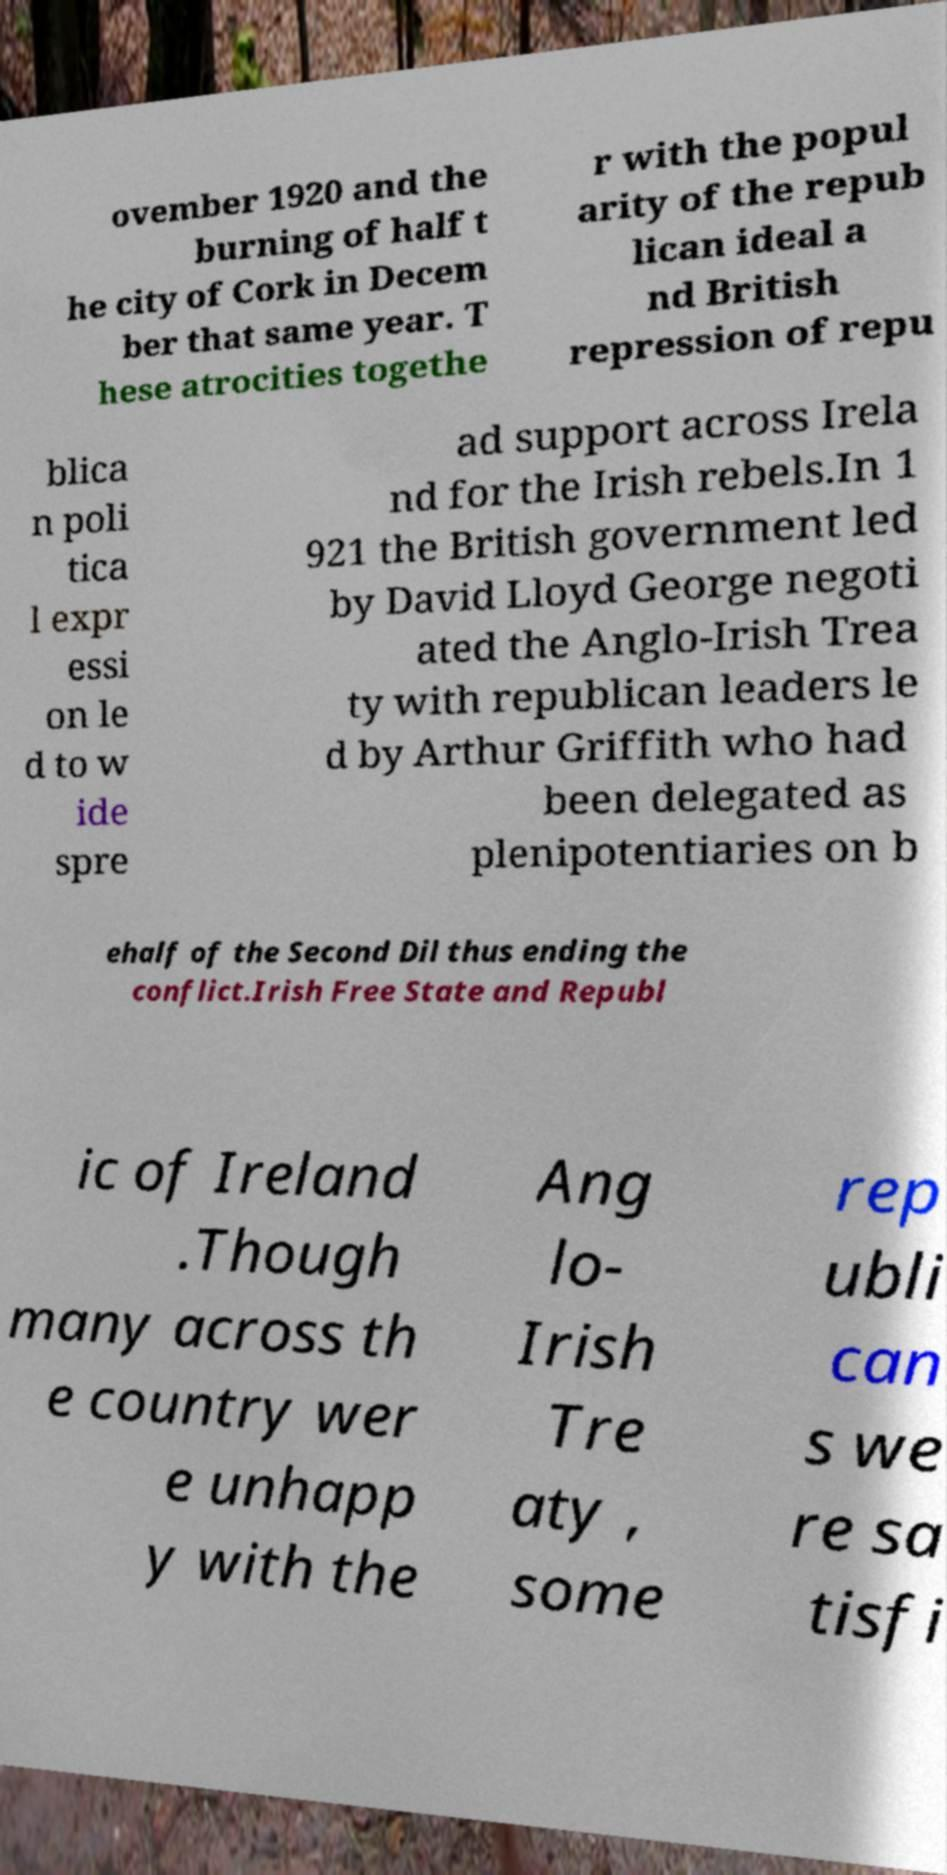Could you assist in decoding the text presented in this image and type it out clearly? ovember 1920 and the burning of half t he city of Cork in Decem ber that same year. T hese atrocities togethe r with the popul arity of the repub lican ideal a nd British repression of repu blica n poli tica l expr essi on le d to w ide spre ad support across Irela nd for the Irish rebels.In 1 921 the British government led by David Lloyd George negoti ated the Anglo-Irish Trea ty with republican leaders le d by Arthur Griffith who had been delegated as plenipotentiaries on b ehalf of the Second Dil thus ending the conflict.Irish Free State and Republ ic of Ireland .Though many across th e country wer e unhapp y with the Ang lo- Irish Tre aty , some rep ubli can s we re sa tisfi 